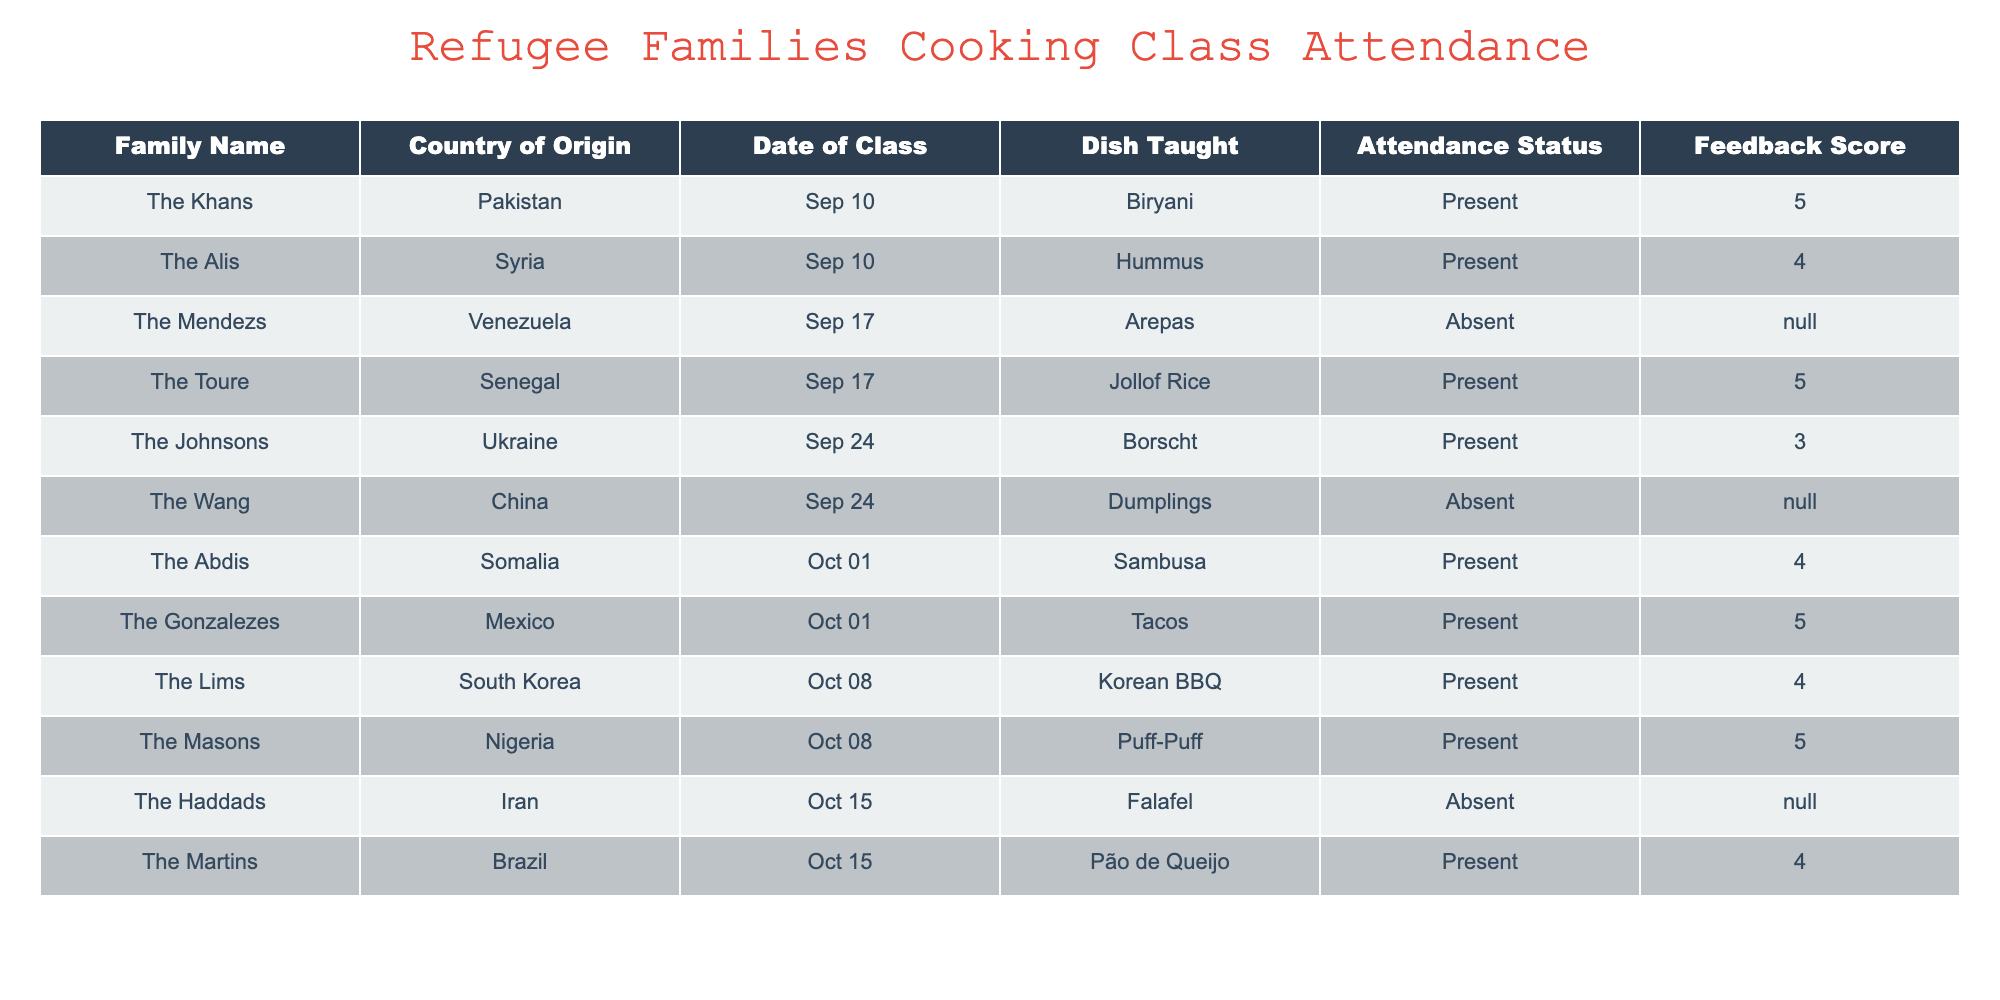What dish did the Alis family learn to cook? The table lists the Alis family under the "Family Name" column, with "Hummus" mentioned in the "Dish Taught" column for the date of class 2023-09-10.
Answer: Hummus How many families were present at the cooking class on October 1st? Referring to the row for the date 2023-10-01, we find two families: The Abdis and The Gonzalezes, marked as "Present."
Answer: 2 What was the feedback score for Jollof Rice? Looking at the table, we see that Jollof Rice was taught to The Toure family, who attended the class. The feedback score recorded for them is 5.
Answer: 5 Did the Wang family attend the class on September 24th? Checking the record for the Wang family, they are listed under the date 2023-09-24 with "Absent" marked in the "Attendance Status" column.
Answer: No What is the average feedback score for all families that were present? To find this, we sum the feedback scores of present families: 5 (Khan) + 4 (Ali) + 4 (Abdi) + 5 (Gonzalez) + 4 (Lim) + 5 (Mason) + 3 (Johnson) = 30. There are 7 present families, so the average is 30/7 ≈ 4.29.
Answer: 4.29 Which family from Somalia attended the class and what dish did they learn? The table shows that The Abdis family, who are from Somalia, attended the class on October 1st and learned to cook Sambusa.
Answer: The Abdis family, Sambusa How many different countries are represented among the families that attended at least one class? By examining the unique entries under the "Country of Origin" column for families that attended, we find Pakistan, Syria, Senegal, Ukraine, Somalia, Mexico, South Korea, Nigeria, and Brazil—totaling 9 distinct countries.
Answer: 9 What dish was taught to the family that scored a 4 on October 15th? The Martins family learned to cook Pão de Queijo on the date of class 2023-10-15, and their feedback score is 4, as indicated by the table.
Answer: Pão de Queijo How many families left feedback after learning the dish on September 10th? Looking at the attendance status for the date 2023-09-10, both families present (The Khans and The Alis) left feedback scores (5 and 4, respectively), thus 2 families provided feedback.
Answer: 2 